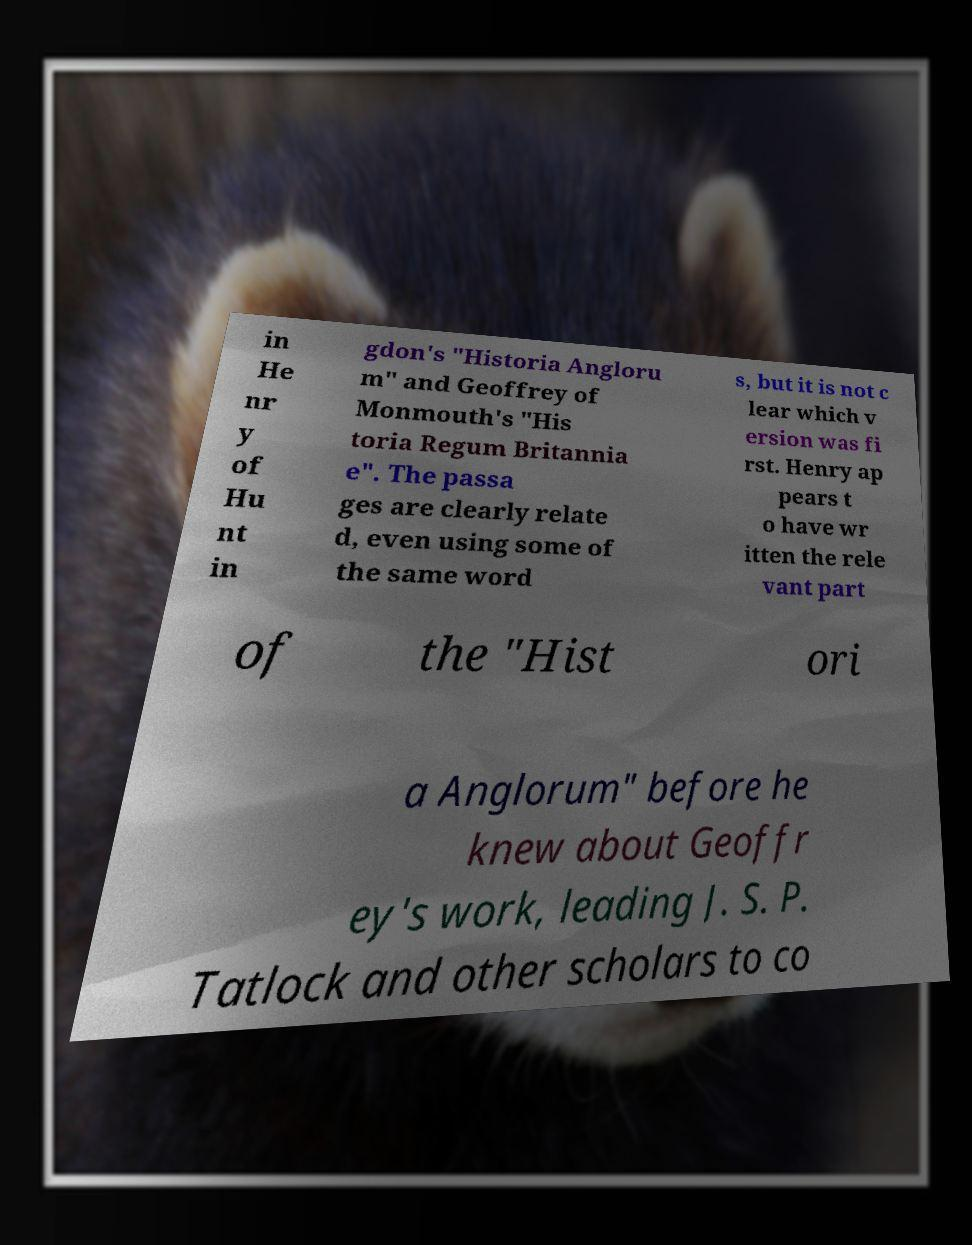There's text embedded in this image that I need extracted. Can you transcribe it verbatim? in He nr y of Hu nt in gdon's "Historia Angloru m" and Geoffrey of Monmouth's "His toria Regum Britannia e". The passa ges are clearly relate d, even using some of the same word s, but it is not c lear which v ersion was fi rst. Henry ap pears t o have wr itten the rele vant part of the "Hist ori a Anglorum" before he knew about Geoffr ey's work, leading J. S. P. Tatlock and other scholars to co 